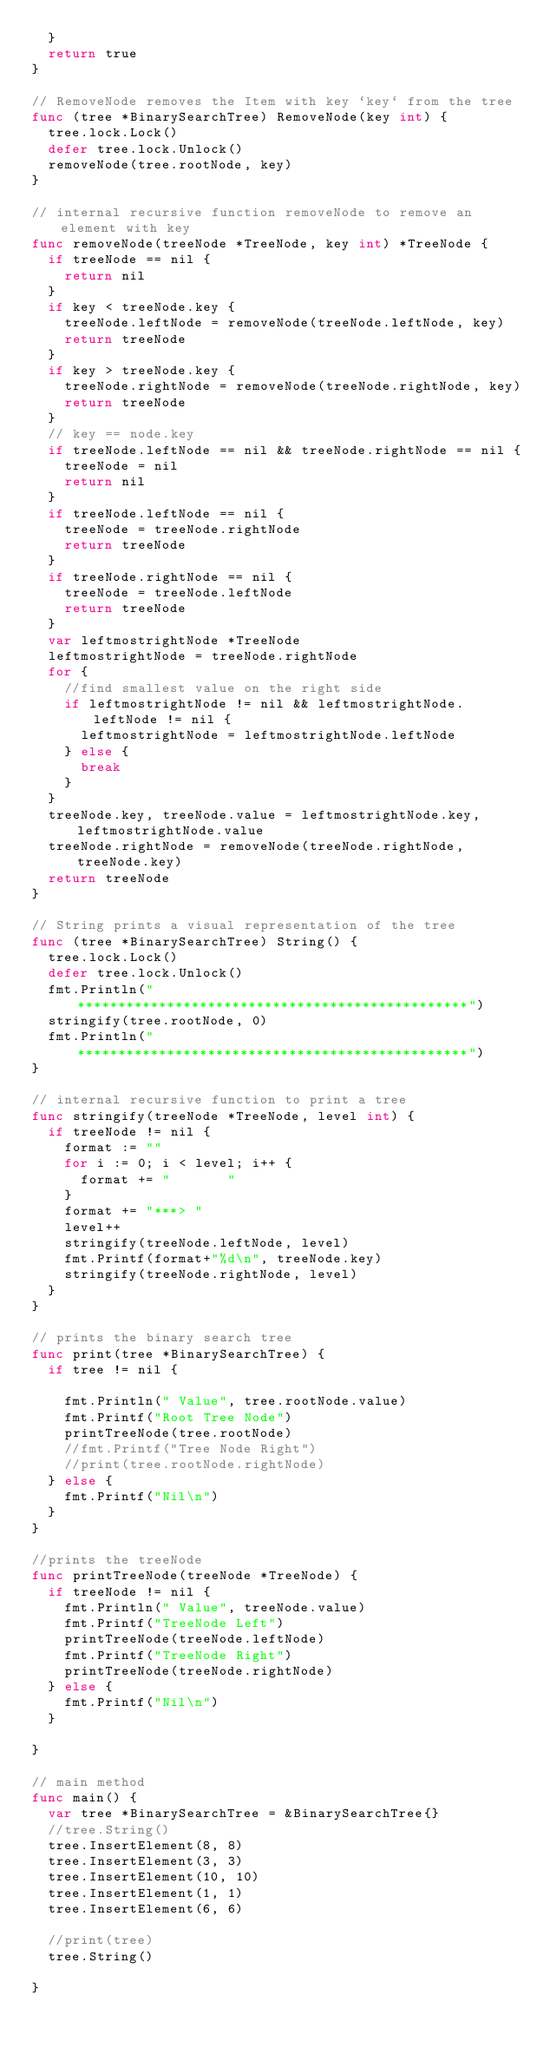<code> <loc_0><loc_0><loc_500><loc_500><_Go_>	}
	return true
}

// RemoveNode removes the Item with key `key` from the tree
func (tree *BinarySearchTree) RemoveNode(key int) {
	tree.lock.Lock()
	defer tree.lock.Unlock()
	removeNode(tree.rootNode, key)
}

// internal recursive function removeNode to remove an element with key
func removeNode(treeNode *TreeNode, key int) *TreeNode {
	if treeNode == nil {
		return nil
	}
	if key < treeNode.key {
		treeNode.leftNode = removeNode(treeNode.leftNode, key)
		return treeNode
	}
	if key > treeNode.key {
		treeNode.rightNode = removeNode(treeNode.rightNode, key)
		return treeNode
	}
	// key == node.key
	if treeNode.leftNode == nil && treeNode.rightNode == nil {
		treeNode = nil
		return nil
	}
	if treeNode.leftNode == nil {
		treeNode = treeNode.rightNode
		return treeNode
	}
	if treeNode.rightNode == nil {
		treeNode = treeNode.leftNode
		return treeNode
	}
	var leftmostrightNode *TreeNode
	leftmostrightNode = treeNode.rightNode
	for {
		//find smallest value on the right side
		if leftmostrightNode != nil && leftmostrightNode.leftNode != nil {
			leftmostrightNode = leftmostrightNode.leftNode
		} else {
			break
		}
	}
	treeNode.key, treeNode.value = leftmostrightNode.key, leftmostrightNode.value
	treeNode.rightNode = removeNode(treeNode.rightNode, treeNode.key)
	return treeNode
}

// String prints a visual representation of the tree
func (tree *BinarySearchTree) String() {
	tree.lock.Lock()
	defer tree.lock.Unlock()
	fmt.Println("************************************************")
	stringify(tree.rootNode, 0)
	fmt.Println("************************************************")
}

// internal recursive function to print a tree
func stringify(treeNode *TreeNode, level int) {
	if treeNode != nil {
		format := ""
		for i := 0; i < level; i++ {
			format += "       "
		}
		format += "***> "
		level++
		stringify(treeNode.leftNode, level)
		fmt.Printf(format+"%d\n", treeNode.key)
		stringify(treeNode.rightNode, level)
	}
}

// prints the binary search tree
func print(tree *BinarySearchTree) {
	if tree != nil {

		fmt.Println(" Value", tree.rootNode.value)
		fmt.Printf("Root Tree Node")
		printTreeNode(tree.rootNode)
		//fmt.Printf("Tree Node Right")
		//print(tree.rootNode.rightNode)
	} else {
		fmt.Printf("Nil\n")
	}
}

//prints the treeNode
func printTreeNode(treeNode *TreeNode) {
	if treeNode != nil {
		fmt.Println(" Value", treeNode.value)
		fmt.Printf("TreeNode Left")
		printTreeNode(treeNode.leftNode)
		fmt.Printf("TreeNode Right")
		printTreeNode(treeNode.rightNode)
	} else {
		fmt.Printf("Nil\n")
	}

}

// main method
func main() {
	var tree *BinarySearchTree = &BinarySearchTree{}
	//tree.String()
	tree.InsertElement(8, 8)
	tree.InsertElement(3, 3)
	tree.InsertElement(10, 10)
	tree.InsertElement(1, 1)
	tree.InsertElement(6, 6)

	//print(tree)
	tree.String()

}
</code> 